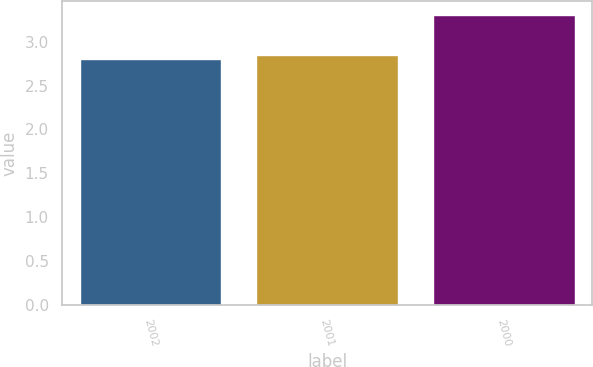<chart> <loc_0><loc_0><loc_500><loc_500><bar_chart><fcel>2002<fcel>2001<fcel>2000<nl><fcel>2.8<fcel>2.85<fcel>3.3<nl></chart> 